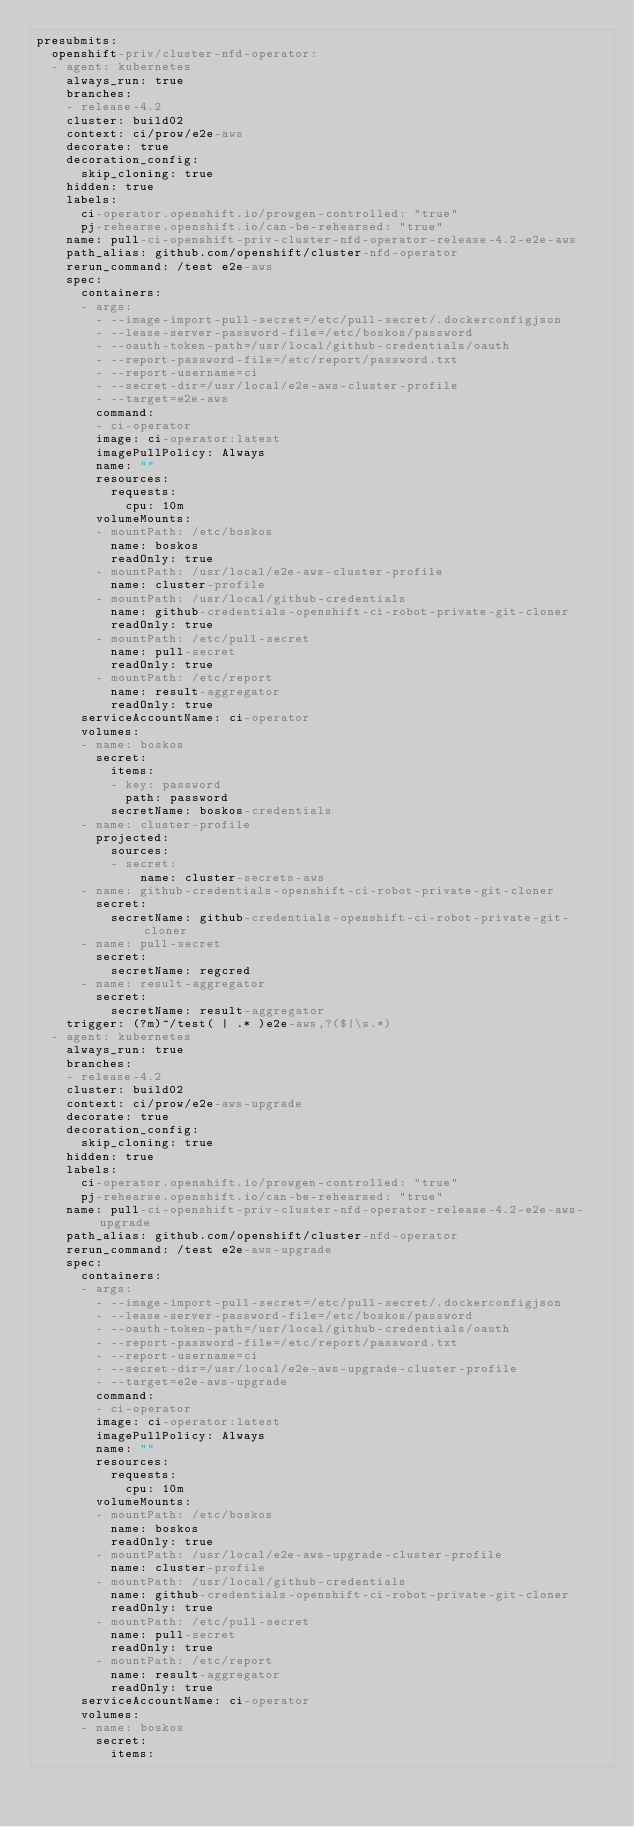Convert code to text. <code><loc_0><loc_0><loc_500><loc_500><_YAML_>presubmits:
  openshift-priv/cluster-nfd-operator:
  - agent: kubernetes
    always_run: true
    branches:
    - release-4.2
    cluster: build02
    context: ci/prow/e2e-aws
    decorate: true
    decoration_config:
      skip_cloning: true
    hidden: true
    labels:
      ci-operator.openshift.io/prowgen-controlled: "true"
      pj-rehearse.openshift.io/can-be-rehearsed: "true"
    name: pull-ci-openshift-priv-cluster-nfd-operator-release-4.2-e2e-aws
    path_alias: github.com/openshift/cluster-nfd-operator
    rerun_command: /test e2e-aws
    spec:
      containers:
      - args:
        - --image-import-pull-secret=/etc/pull-secret/.dockerconfigjson
        - --lease-server-password-file=/etc/boskos/password
        - --oauth-token-path=/usr/local/github-credentials/oauth
        - --report-password-file=/etc/report/password.txt
        - --report-username=ci
        - --secret-dir=/usr/local/e2e-aws-cluster-profile
        - --target=e2e-aws
        command:
        - ci-operator
        image: ci-operator:latest
        imagePullPolicy: Always
        name: ""
        resources:
          requests:
            cpu: 10m
        volumeMounts:
        - mountPath: /etc/boskos
          name: boskos
          readOnly: true
        - mountPath: /usr/local/e2e-aws-cluster-profile
          name: cluster-profile
        - mountPath: /usr/local/github-credentials
          name: github-credentials-openshift-ci-robot-private-git-cloner
          readOnly: true
        - mountPath: /etc/pull-secret
          name: pull-secret
          readOnly: true
        - mountPath: /etc/report
          name: result-aggregator
          readOnly: true
      serviceAccountName: ci-operator
      volumes:
      - name: boskos
        secret:
          items:
          - key: password
            path: password
          secretName: boskos-credentials
      - name: cluster-profile
        projected:
          sources:
          - secret:
              name: cluster-secrets-aws
      - name: github-credentials-openshift-ci-robot-private-git-cloner
        secret:
          secretName: github-credentials-openshift-ci-robot-private-git-cloner
      - name: pull-secret
        secret:
          secretName: regcred
      - name: result-aggregator
        secret:
          secretName: result-aggregator
    trigger: (?m)^/test( | .* )e2e-aws,?($|\s.*)
  - agent: kubernetes
    always_run: true
    branches:
    - release-4.2
    cluster: build02
    context: ci/prow/e2e-aws-upgrade
    decorate: true
    decoration_config:
      skip_cloning: true
    hidden: true
    labels:
      ci-operator.openshift.io/prowgen-controlled: "true"
      pj-rehearse.openshift.io/can-be-rehearsed: "true"
    name: pull-ci-openshift-priv-cluster-nfd-operator-release-4.2-e2e-aws-upgrade
    path_alias: github.com/openshift/cluster-nfd-operator
    rerun_command: /test e2e-aws-upgrade
    spec:
      containers:
      - args:
        - --image-import-pull-secret=/etc/pull-secret/.dockerconfigjson
        - --lease-server-password-file=/etc/boskos/password
        - --oauth-token-path=/usr/local/github-credentials/oauth
        - --report-password-file=/etc/report/password.txt
        - --report-username=ci
        - --secret-dir=/usr/local/e2e-aws-upgrade-cluster-profile
        - --target=e2e-aws-upgrade
        command:
        - ci-operator
        image: ci-operator:latest
        imagePullPolicy: Always
        name: ""
        resources:
          requests:
            cpu: 10m
        volumeMounts:
        - mountPath: /etc/boskos
          name: boskos
          readOnly: true
        - mountPath: /usr/local/e2e-aws-upgrade-cluster-profile
          name: cluster-profile
        - mountPath: /usr/local/github-credentials
          name: github-credentials-openshift-ci-robot-private-git-cloner
          readOnly: true
        - mountPath: /etc/pull-secret
          name: pull-secret
          readOnly: true
        - mountPath: /etc/report
          name: result-aggregator
          readOnly: true
      serviceAccountName: ci-operator
      volumes:
      - name: boskos
        secret:
          items:</code> 